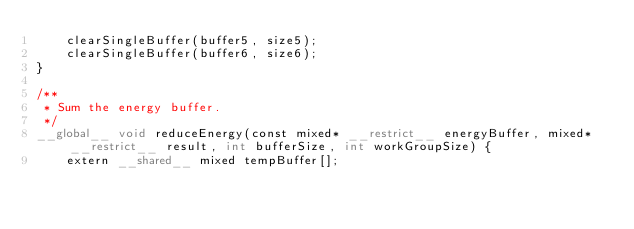<code> <loc_0><loc_0><loc_500><loc_500><_Cuda_>    clearSingleBuffer(buffer5, size5);
    clearSingleBuffer(buffer6, size6);
}

/**
 * Sum the energy buffer.
 */
__global__ void reduceEnergy(const mixed* __restrict__ energyBuffer, mixed* __restrict__ result, int bufferSize, int workGroupSize) {
    extern __shared__ mixed tempBuffer[];</code> 